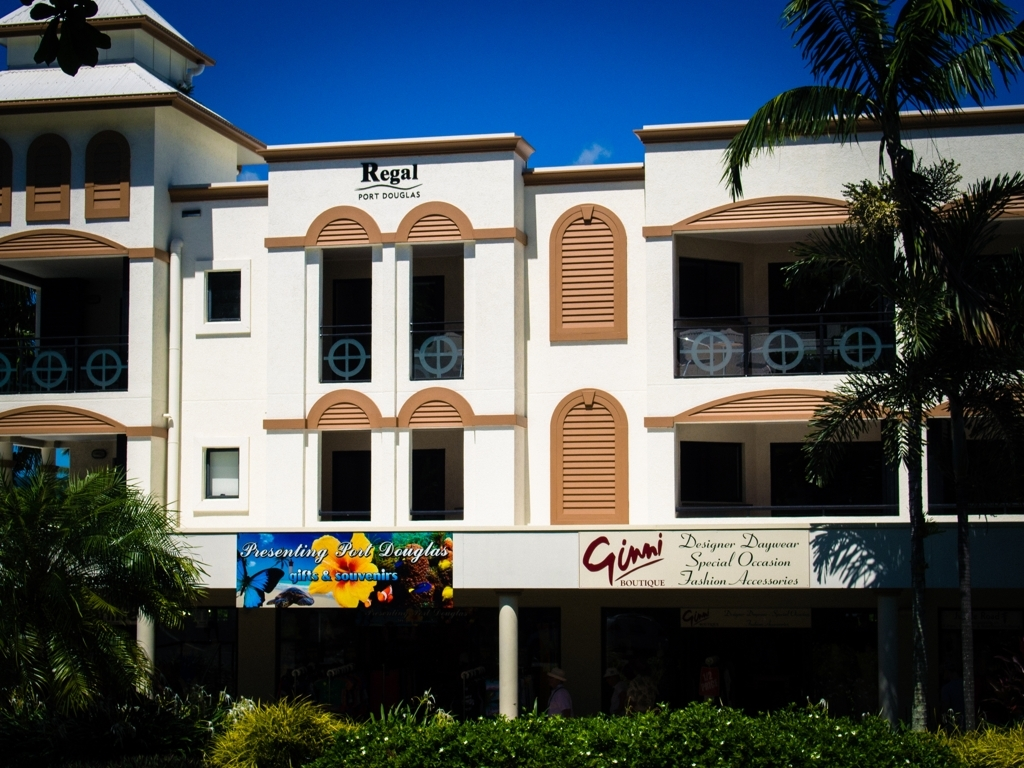Can you tell me about the architectural style of this building? The building features a simple modern architectural style with Mediterranean influences, noticeable from the use of arched windows and shutters. The structure is symmetrical with a clear emphasis on clean lines and functional design. What kind of businesses might be found in this building? Based on the signage, the building houses various businesses, including a boutique called 'Ginni' which seems to specialize in designer daywear, special occasion fashion, and accessories. There's also a sign indicating 'Presenting Port Douglas,' which may suggest a tourist or visitor information center offering souvenirs. 